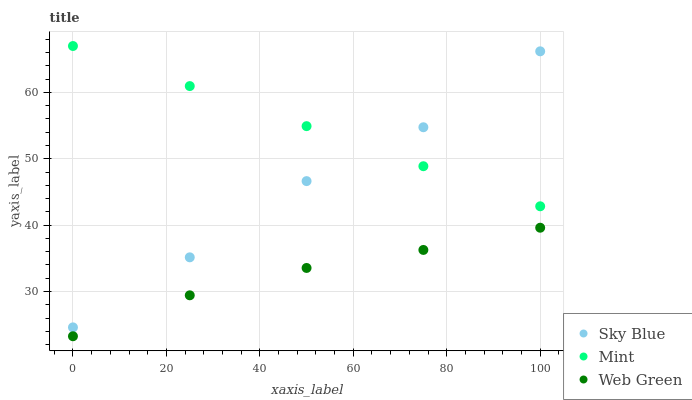Does Web Green have the minimum area under the curve?
Answer yes or no. Yes. Does Mint have the maximum area under the curve?
Answer yes or no. Yes. Does Mint have the minimum area under the curve?
Answer yes or no. No. Does Web Green have the maximum area under the curve?
Answer yes or no. No. Is Mint the smoothest?
Answer yes or no. Yes. Is Sky Blue the roughest?
Answer yes or no. Yes. Is Web Green the smoothest?
Answer yes or no. No. Is Web Green the roughest?
Answer yes or no. No. Does Web Green have the lowest value?
Answer yes or no. Yes. Does Mint have the lowest value?
Answer yes or no. No. Does Mint have the highest value?
Answer yes or no. Yes. Does Web Green have the highest value?
Answer yes or no. No. Is Web Green less than Mint?
Answer yes or no. Yes. Is Sky Blue greater than Web Green?
Answer yes or no. Yes. Does Sky Blue intersect Mint?
Answer yes or no. Yes. Is Sky Blue less than Mint?
Answer yes or no. No. Is Sky Blue greater than Mint?
Answer yes or no. No. Does Web Green intersect Mint?
Answer yes or no. No. 